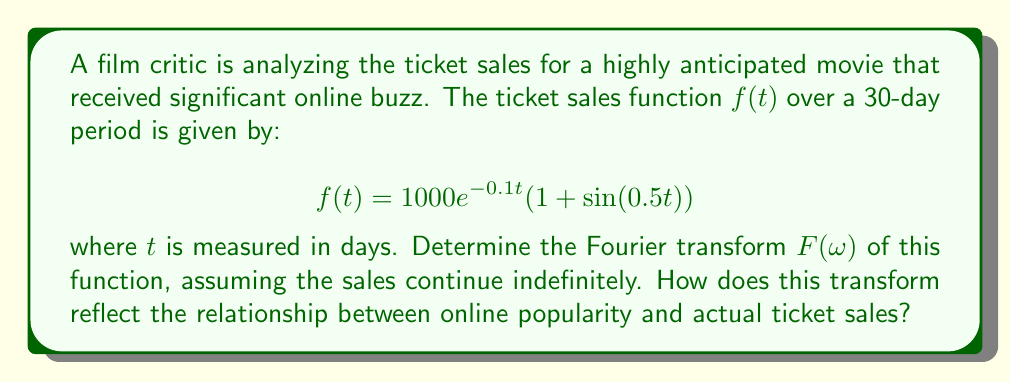Could you help me with this problem? To find the Fourier transform of $f(t)$, we follow these steps:

1) The Fourier transform is defined as:
   $$F(\omega) = \int_{-\infty}^{\infty} f(t)e^{-i\omega t} dt$$

2) Substituting our function:
   $$F(\omega) = \int_{-\infty}^{\infty} 1000e^{-0.1t}(1 + \sin(0.5t))e^{-i\omega t} dt$$

3) This can be split into two integrals:
   $$F(\omega) = 1000\int_{-\infty}^{\infty} e^{-0.1t}e^{-i\omega t} dt + 1000\int_{-\infty}^{\infty} e^{-0.1t}\sin(0.5t)e^{-i\omega t} dt$$

4) The first integral is the Fourier transform of an exponential decay:
   $$1000\int_{-\infty}^{\infty} e^{-0.1t}e^{-i\omega t} dt = \frac{1000}{0.1 + i\omega}$$

5) For the second integral, we use the identity $\sin(0.5t) = \frac{e^{i0.5t} - e^{-i0.5t}}{2i}$:
   $$1000\int_{-\infty}^{\infty} e^{-0.1t}\frac{e^{i0.5t} - e^{-i0.5t}}{2i}e^{-i\omega t} dt$$
   
   $$= \frac{500}{i}\left(\frac{1}{0.1 + i(\omega - 0.5)} - \frac{1}{0.1 + i(\omega + 0.5)}\right)$$

6) Combining the results:
   $$F(\omega) = \frac{1000}{0.1 + i\omega} + \frac{500}{i}\left(\frac{1}{0.1 + i(\omega - 0.5)} - \frac{1}{0.1 + i(\omega + 0.5)}\right)$$

This transform shows a main peak at $\omega = 0$ (representing the overall decay trend) and two smaller peaks at $\omega = \pm 0.5$ (representing the sinusoidal fluctuation). The presence of these side peaks indicates that online buzz may cause periodic surges in ticket sales, but the dominant exponential decay suggests that this popularity does not sustain long-term profitability.
Answer: $$F(\omega) = \frac{1000}{0.1 + i\omega} + \frac{500}{i}\left(\frac{1}{0.1 + i(\omega - 0.5)} - \frac{1}{0.1 + i(\omega + 0.5)}\right)$$ 